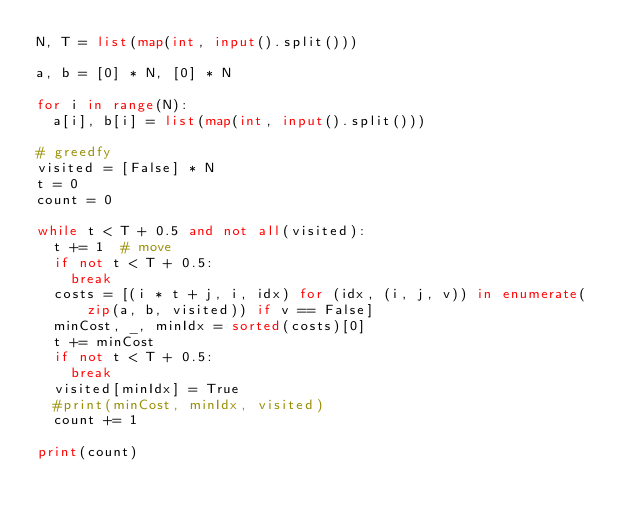Convert code to text. <code><loc_0><loc_0><loc_500><loc_500><_Python_>N, T = list(map(int, input().split()))

a, b = [0] * N, [0] * N

for i in range(N):
  a[i], b[i] = list(map(int, input().split()))

# greedfy
visited = [False] * N
t = 0
count = 0

while t < T + 0.5 and not all(visited):
  t += 1  # move
  if not t < T + 0.5:
    break
  costs = [(i * t + j, i, idx) for (idx, (i, j, v)) in enumerate(zip(a, b, visited)) if v == False]
  minCost, _, minIdx = sorted(costs)[0]
  t += minCost
  if not t < T + 0.5:
    break
  visited[minIdx] = True
  #print(minCost, minIdx, visited)
  count += 1

print(count)
</code> 